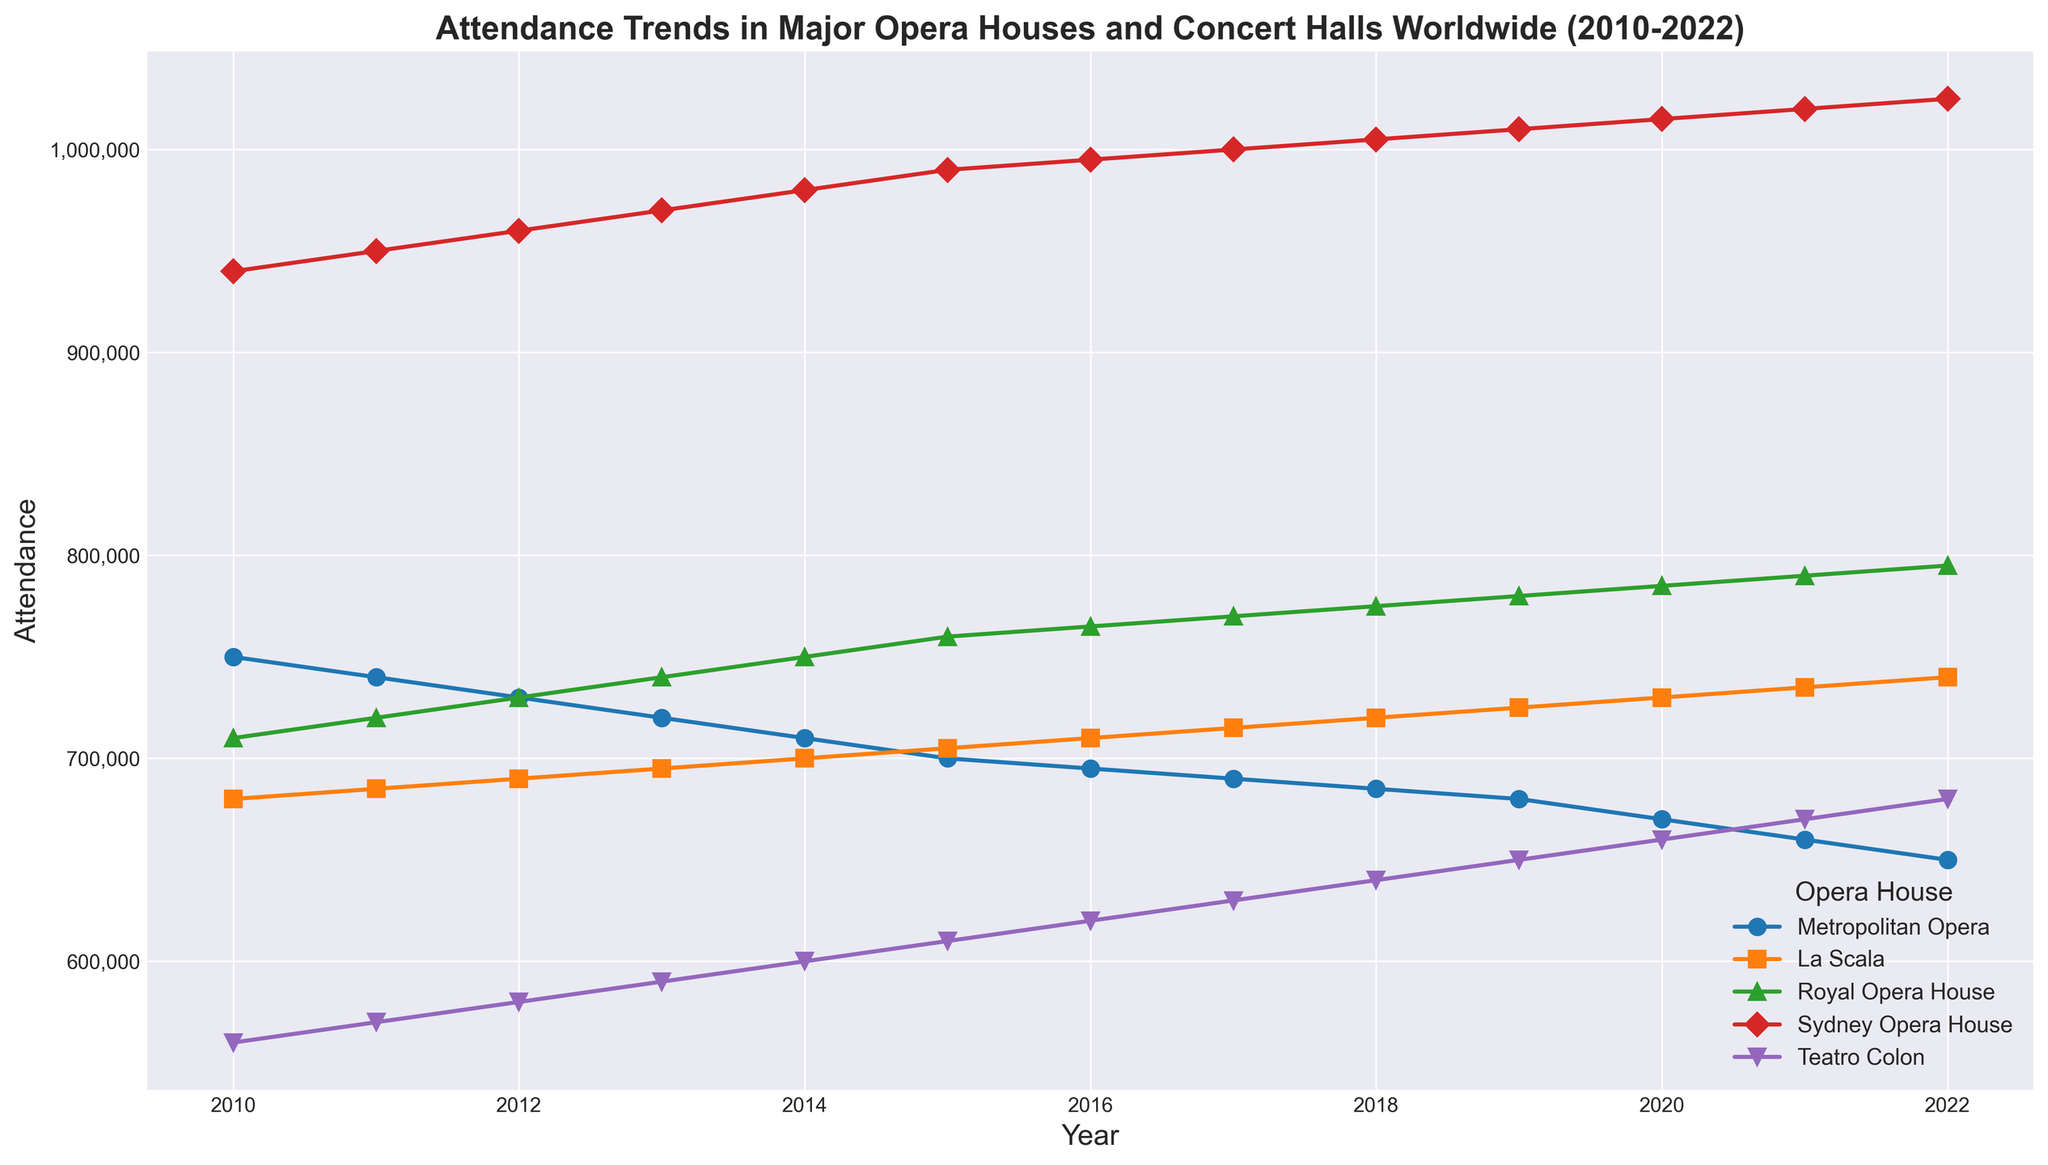Which Opera House had the highest attendance in 2014? Look at the data points for 2014 across all Opera Houses. The highest point corresponds to the Sydney Opera House.
Answer: Sydney Opera House What's the difference in attendance between the Sydney Opera House and the Metropolitan Opera in 2020? Find the attendance values for both the Sydney Opera House and the Metropolitan Opera in 2020: 1,015,000 - 670,000.
Answer: 345,000 Which Opera House shows a consistent increase in attendance from 2010 to 2022? Look for a line that consistently trends upwards across these years. The Royal Opera House and La Scala both display consistent increases.
Answer: Royal Opera House, La Scala Which year had the lowest attendance for the Metropolitan Opera? Identify the year when the Metropolitan Opera's trend line is at its lowest point: it dips lowest at 2022.
Answer: 2022 What is the average attendance of Teatro Colon over the years shown? Sum the attendance values for Teatro Colon from 2010 to 2022 and divide by the number of years (13). The sum of the values is 7,670,000. Dividing by 13 gives the average.
Answer: 590,000 How does the attendance trend of La Scala compare to that of the Sydney Opera House over the years? Compare the trend lines of both. Sydney Opera House shows a higher and more consistent rising trend, whereas La Scala also rises but more gradually.
Answer: Sydney Opera House has a steeper increase Do any of the Opera Houses show a declining trend over these years? Look for downward-sloping lines from 2010 to 2022. The Metropolitan Opera shows a declining trend.
Answer: Metropolitan Opera What's the total attendance for Royal Opera House from 2010 to 2022? Sum the attendance values for Royal Opera House over these years: 710,000 + 720,000 + 730,000 + 740,000 + 750,000 + 760,000 + 765,000 + 770,000 + 775,000 + 780,000 + 785,000 + 790,000 + 795,000.
Answer: 9,370,000 Which Opera House had the least variation in attendance from 2010 to 2022? Look for a line that is the most stable (least fluctuating). La Scala seems to have a steady increase without significant fluctuations compared to the others.
Answer: La Scala 